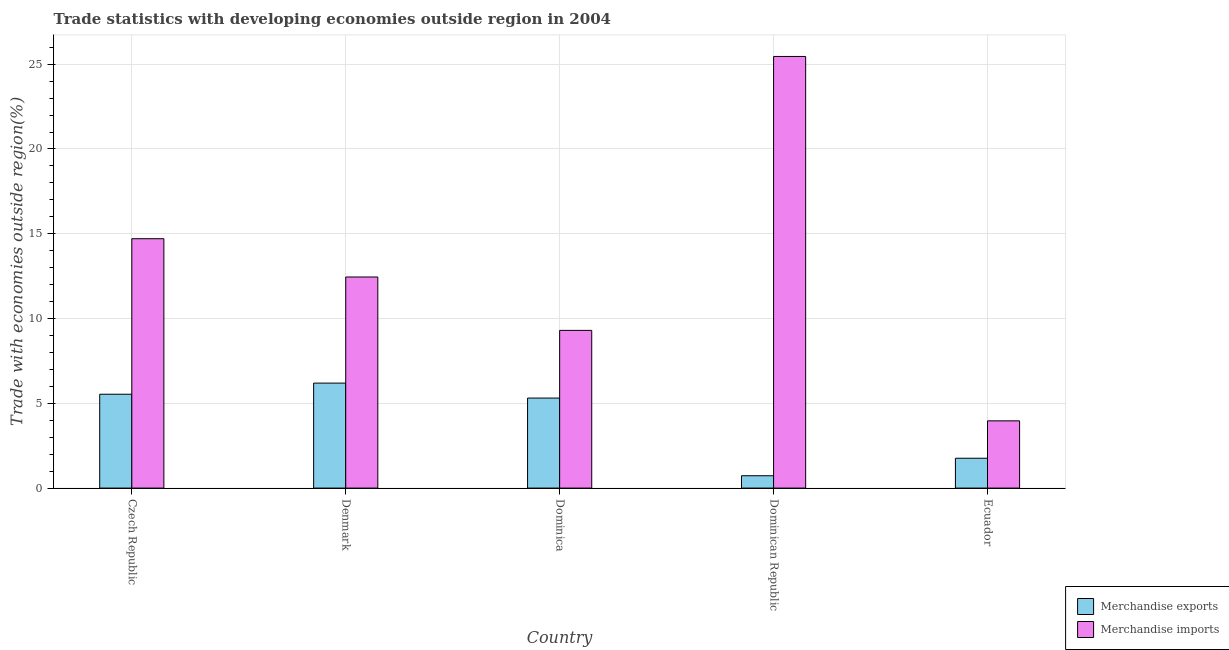How many different coloured bars are there?
Make the answer very short. 2. Are the number of bars on each tick of the X-axis equal?
Provide a short and direct response. Yes. How many bars are there on the 1st tick from the left?
Your response must be concise. 2. How many bars are there on the 5th tick from the right?
Ensure brevity in your answer.  2. What is the label of the 1st group of bars from the left?
Your response must be concise. Czech Republic. In how many cases, is the number of bars for a given country not equal to the number of legend labels?
Offer a very short reply. 0. What is the merchandise exports in Denmark?
Offer a terse response. 6.19. Across all countries, what is the maximum merchandise exports?
Provide a short and direct response. 6.19. Across all countries, what is the minimum merchandise exports?
Give a very brief answer. 0.73. In which country was the merchandise imports minimum?
Make the answer very short. Ecuador. What is the total merchandise imports in the graph?
Your answer should be compact. 65.88. What is the difference between the merchandise exports in Czech Republic and that in Dominica?
Your answer should be very brief. 0.23. What is the difference between the merchandise exports in Denmark and the merchandise imports in Dominican Republic?
Keep it short and to the point. -19.27. What is the average merchandise imports per country?
Give a very brief answer. 13.18. What is the difference between the merchandise exports and merchandise imports in Dominican Republic?
Offer a terse response. -24.73. In how many countries, is the merchandise imports greater than 17 %?
Provide a succinct answer. 1. What is the ratio of the merchandise imports in Dominica to that in Dominican Republic?
Keep it short and to the point. 0.37. What is the difference between the highest and the second highest merchandise imports?
Make the answer very short. 10.75. What is the difference between the highest and the lowest merchandise imports?
Provide a succinct answer. 21.49. In how many countries, is the merchandise imports greater than the average merchandise imports taken over all countries?
Ensure brevity in your answer.  2. Is the sum of the merchandise exports in Czech Republic and Ecuador greater than the maximum merchandise imports across all countries?
Make the answer very short. No. What does the 1st bar from the right in Ecuador represents?
Offer a very short reply. Merchandise imports. How many bars are there?
Make the answer very short. 10. Are the values on the major ticks of Y-axis written in scientific E-notation?
Ensure brevity in your answer.  No. Does the graph contain grids?
Ensure brevity in your answer.  Yes. Where does the legend appear in the graph?
Offer a very short reply. Bottom right. How many legend labels are there?
Provide a short and direct response. 2. How are the legend labels stacked?
Your answer should be very brief. Vertical. What is the title of the graph?
Ensure brevity in your answer.  Trade statistics with developing economies outside region in 2004. What is the label or title of the X-axis?
Offer a very short reply. Country. What is the label or title of the Y-axis?
Make the answer very short. Trade with economies outside region(%). What is the Trade with economies outside region(%) of Merchandise exports in Czech Republic?
Offer a terse response. 5.54. What is the Trade with economies outside region(%) in Merchandise imports in Czech Republic?
Give a very brief answer. 14.71. What is the Trade with economies outside region(%) of Merchandise exports in Denmark?
Ensure brevity in your answer.  6.19. What is the Trade with economies outside region(%) in Merchandise imports in Denmark?
Your answer should be compact. 12.45. What is the Trade with economies outside region(%) in Merchandise exports in Dominica?
Your answer should be very brief. 5.31. What is the Trade with economies outside region(%) of Merchandise imports in Dominica?
Provide a short and direct response. 9.3. What is the Trade with economies outside region(%) of Merchandise exports in Dominican Republic?
Your answer should be compact. 0.73. What is the Trade with economies outside region(%) of Merchandise imports in Dominican Republic?
Your response must be concise. 25.46. What is the Trade with economies outside region(%) in Merchandise exports in Ecuador?
Provide a succinct answer. 1.76. What is the Trade with economies outside region(%) in Merchandise imports in Ecuador?
Your answer should be compact. 3.97. Across all countries, what is the maximum Trade with economies outside region(%) of Merchandise exports?
Offer a very short reply. 6.19. Across all countries, what is the maximum Trade with economies outside region(%) of Merchandise imports?
Your answer should be compact. 25.46. Across all countries, what is the minimum Trade with economies outside region(%) of Merchandise exports?
Your answer should be compact. 0.73. Across all countries, what is the minimum Trade with economies outside region(%) of Merchandise imports?
Offer a terse response. 3.97. What is the total Trade with economies outside region(%) in Merchandise exports in the graph?
Give a very brief answer. 19.53. What is the total Trade with economies outside region(%) of Merchandise imports in the graph?
Your answer should be compact. 65.88. What is the difference between the Trade with economies outside region(%) in Merchandise exports in Czech Republic and that in Denmark?
Ensure brevity in your answer.  -0.66. What is the difference between the Trade with economies outside region(%) in Merchandise imports in Czech Republic and that in Denmark?
Make the answer very short. 2.26. What is the difference between the Trade with economies outside region(%) of Merchandise exports in Czech Republic and that in Dominica?
Offer a very short reply. 0.23. What is the difference between the Trade with economies outside region(%) in Merchandise imports in Czech Republic and that in Dominica?
Ensure brevity in your answer.  5.41. What is the difference between the Trade with economies outside region(%) of Merchandise exports in Czech Republic and that in Dominican Republic?
Your response must be concise. 4.81. What is the difference between the Trade with economies outside region(%) of Merchandise imports in Czech Republic and that in Dominican Republic?
Provide a succinct answer. -10.75. What is the difference between the Trade with economies outside region(%) in Merchandise exports in Czech Republic and that in Ecuador?
Your response must be concise. 3.78. What is the difference between the Trade with economies outside region(%) in Merchandise imports in Czech Republic and that in Ecuador?
Give a very brief answer. 10.74. What is the difference between the Trade with economies outside region(%) of Merchandise exports in Denmark and that in Dominica?
Make the answer very short. 0.88. What is the difference between the Trade with economies outside region(%) of Merchandise imports in Denmark and that in Dominica?
Your answer should be very brief. 3.15. What is the difference between the Trade with economies outside region(%) in Merchandise exports in Denmark and that in Dominican Republic?
Your answer should be compact. 5.46. What is the difference between the Trade with economies outside region(%) of Merchandise imports in Denmark and that in Dominican Republic?
Ensure brevity in your answer.  -13.01. What is the difference between the Trade with economies outside region(%) in Merchandise exports in Denmark and that in Ecuador?
Offer a very short reply. 4.43. What is the difference between the Trade with economies outside region(%) in Merchandise imports in Denmark and that in Ecuador?
Provide a succinct answer. 8.48. What is the difference between the Trade with economies outside region(%) in Merchandise exports in Dominica and that in Dominican Republic?
Offer a very short reply. 4.58. What is the difference between the Trade with economies outside region(%) in Merchandise imports in Dominica and that in Dominican Republic?
Offer a terse response. -16.16. What is the difference between the Trade with economies outside region(%) of Merchandise exports in Dominica and that in Ecuador?
Keep it short and to the point. 3.55. What is the difference between the Trade with economies outside region(%) of Merchandise imports in Dominica and that in Ecuador?
Your response must be concise. 5.34. What is the difference between the Trade with economies outside region(%) of Merchandise exports in Dominican Republic and that in Ecuador?
Your response must be concise. -1.03. What is the difference between the Trade with economies outside region(%) of Merchandise imports in Dominican Republic and that in Ecuador?
Your answer should be very brief. 21.49. What is the difference between the Trade with economies outside region(%) in Merchandise exports in Czech Republic and the Trade with economies outside region(%) in Merchandise imports in Denmark?
Offer a terse response. -6.91. What is the difference between the Trade with economies outside region(%) in Merchandise exports in Czech Republic and the Trade with economies outside region(%) in Merchandise imports in Dominica?
Offer a very short reply. -3.77. What is the difference between the Trade with economies outside region(%) in Merchandise exports in Czech Republic and the Trade with economies outside region(%) in Merchandise imports in Dominican Republic?
Offer a very short reply. -19.92. What is the difference between the Trade with economies outside region(%) in Merchandise exports in Czech Republic and the Trade with economies outside region(%) in Merchandise imports in Ecuador?
Make the answer very short. 1.57. What is the difference between the Trade with economies outside region(%) in Merchandise exports in Denmark and the Trade with economies outside region(%) in Merchandise imports in Dominica?
Provide a succinct answer. -3.11. What is the difference between the Trade with economies outside region(%) in Merchandise exports in Denmark and the Trade with economies outside region(%) in Merchandise imports in Dominican Republic?
Make the answer very short. -19.27. What is the difference between the Trade with economies outside region(%) in Merchandise exports in Denmark and the Trade with economies outside region(%) in Merchandise imports in Ecuador?
Your response must be concise. 2.23. What is the difference between the Trade with economies outside region(%) in Merchandise exports in Dominica and the Trade with economies outside region(%) in Merchandise imports in Dominican Republic?
Ensure brevity in your answer.  -20.15. What is the difference between the Trade with economies outside region(%) of Merchandise exports in Dominica and the Trade with economies outside region(%) of Merchandise imports in Ecuador?
Provide a short and direct response. 1.34. What is the difference between the Trade with economies outside region(%) of Merchandise exports in Dominican Republic and the Trade with economies outside region(%) of Merchandise imports in Ecuador?
Your answer should be very brief. -3.24. What is the average Trade with economies outside region(%) in Merchandise exports per country?
Your answer should be very brief. 3.91. What is the average Trade with economies outside region(%) of Merchandise imports per country?
Your answer should be very brief. 13.18. What is the difference between the Trade with economies outside region(%) of Merchandise exports and Trade with economies outside region(%) of Merchandise imports in Czech Republic?
Offer a terse response. -9.17. What is the difference between the Trade with economies outside region(%) of Merchandise exports and Trade with economies outside region(%) of Merchandise imports in Denmark?
Offer a very short reply. -6.26. What is the difference between the Trade with economies outside region(%) in Merchandise exports and Trade with economies outside region(%) in Merchandise imports in Dominica?
Offer a very short reply. -3.99. What is the difference between the Trade with economies outside region(%) in Merchandise exports and Trade with economies outside region(%) in Merchandise imports in Dominican Republic?
Make the answer very short. -24.73. What is the difference between the Trade with economies outside region(%) of Merchandise exports and Trade with economies outside region(%) of Merchandise imports in Ecuador?
Keep it short and to the point. -2.21. What is the ratio of the Trade with economies outside region(%) of Merchandise exports in Czech Republic to that in Denmark?
Your answer should be compact. 0.89. What is the ratio of the Trade with economies outside region(%) in Merchandise imports in Czech Republic to that in Denmark?
Your answer should be very brief. 1.18. What is the ratio of the Trade with economies outside region(%) in Merchandise exports in Czech Republic to that in Dominica?
Your response must be concise. 1.04. What is the ratio of the Trade with economies outside region(%) in Merchandise imports in Czech Republic to that in Dominica?
Provide a short and direct response. 1.58. What is the ratio of the Trade with economies outside region(%) of Merchandise exports in Czech Republic to that in Dominican Republic?
Your answer should be compact. 7.6. What is the ratio of the Trade with economies outside region(%) of Merchandise imports in Czech Republic to that in Dominican Republic?
Offer a terse response. 0.58. What is the ratio of the Trade with economies outside region(%) in Merchandise exports in Czech Republic to that in Ecuador?
Give a very brief answer. 3.14. What is the ratio of the Trade with economies outside region(%) in Merchandise imports in Czech Republic to that in Ecuador?
Make the answer very short. 3.71. What is the ratio of the Trade with economies outside region(%) in Merchandise exports in Denmark to that in Dominica?
Provide a short and direct response. 1.17. What is the ratio of the Trade with economies outside region(%) of Merchandise imports in Denmark to that in Dominica?
Your answer should be compact. 1.34. What is the ratio of the Trade with economies outside region(%) in Merchandise exports in Denmark to that in Dominican Republic?
Give a very brief answer. 8.5. What is the ratio of the Trade with economies outside region(%) in Merchandise imports in Denmark to that in Dominican Republic?
Keep it short and to the point. 0.49. What is the ratio of the Trade with economies outside region(%) in Merchandise exports in Denmark to that in Ecuador?
Make the answer very short. 3.52. What is the ratio of the Trade with economies outside region(%) in Merchandise imports in Denmark to that in Ecuador?
Offer a terse response. 3.14. What is the ratio of the Trade with economies outside region(%) of Merchandise exports in Dominica to that in Dominican Republic?
Give a very brief answer. 7.29. What is the ratio of the Trade with economies outside region(%) of Merchandise imports in Dominica to that in Dominican Republic?
Ensure brevity in your answer.  0.37. What is the ratio of the Trade with economies outside region(%) of Merchandise exports in Dominica to that in Ecuador?
Your response must be concise. 3.02. What is the ratio of the Trade with economies outside region(%) of Merchandise imports in Dominica to that in Ecuador?
Make the answer very short. 2.35. What is the ratio of the Trade with economies outside region(%) of Merchandise exports in Dominican Republic to that in Ecuador?
Offer a very short reply. 0.41. What is the ratio of the Trade with economies outside region(%) in Merchandise imports in Dominican Republic to that in Ecuador?
Ensure brevity in your answer.  6.42. What is the difference between the highest and the second highest Trade with economies outside region(%) in Merchandise exports?
Your answer should be compact. 0.66. What is the difference between the highest and the second highest Trade with economies outside region(%) in Merchandise imports?
Make the answer very short. 10.75. What is the difference between the highest and the lowest Trade with economies outside region(%) of Merchandise exports?
Provide a succinct answer. 5.46. What is the difference between the highest and the lowest Trade with economies outside region(%) in Merchandise imports?
Provide a succinct answer. 21.49. 